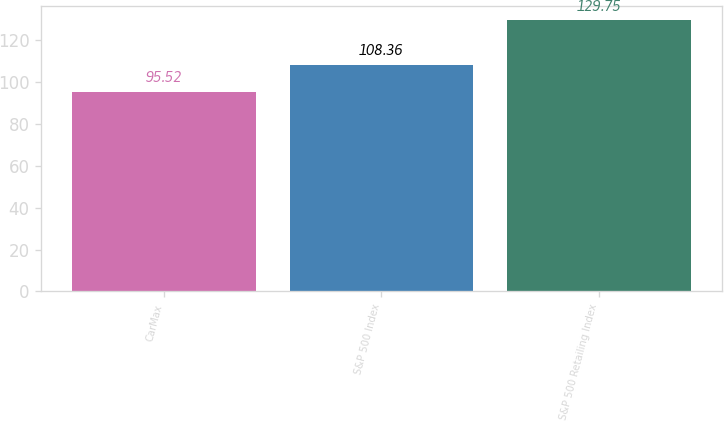Convert chart. <chart><loc_0><loc_0><loc_500><loc_500><bar_chart><fcel>CarMax<fcel>S&P 500 Index<fcel>S&P 500 Retailing Index<nl><fcel>95.52<fcel>108.36<fcel>129.75<nl></chart> 